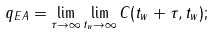Convert formula to latex. <formula><loc_0><loc_0><loc_500><loc_500>q _ { E A } = \lim _ { \tau \rightarrow \infty } \lim _ { t _ { w } \rightarrow \infty } C ( t _ { w } + \tau , t _ { w } ) ;</formula> 